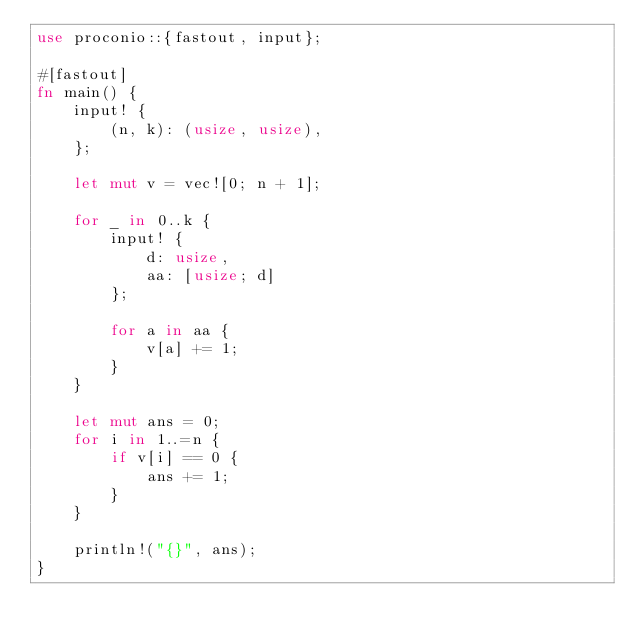<code> <loc_0><loc_0><loc_500><loc_500><_Rust_>use proconio::{fastout, input};

#[fastout]
fn main() {
    input! {
        (n, k): (usize, usize),
    };

    let mut v = vec![0; n + 1];

    for _ in 0..k {
        input! {
            d: usize,
            aa: [usize; d]
        };

        for a in aa {
            v[a] += 1;
        }
    }

    let mut ans = 0;
    for i in 1..=n {
        if v[i] == 0 {
            ans += 1;
        }
    }

    println!("{}", ans);
}
</code> 